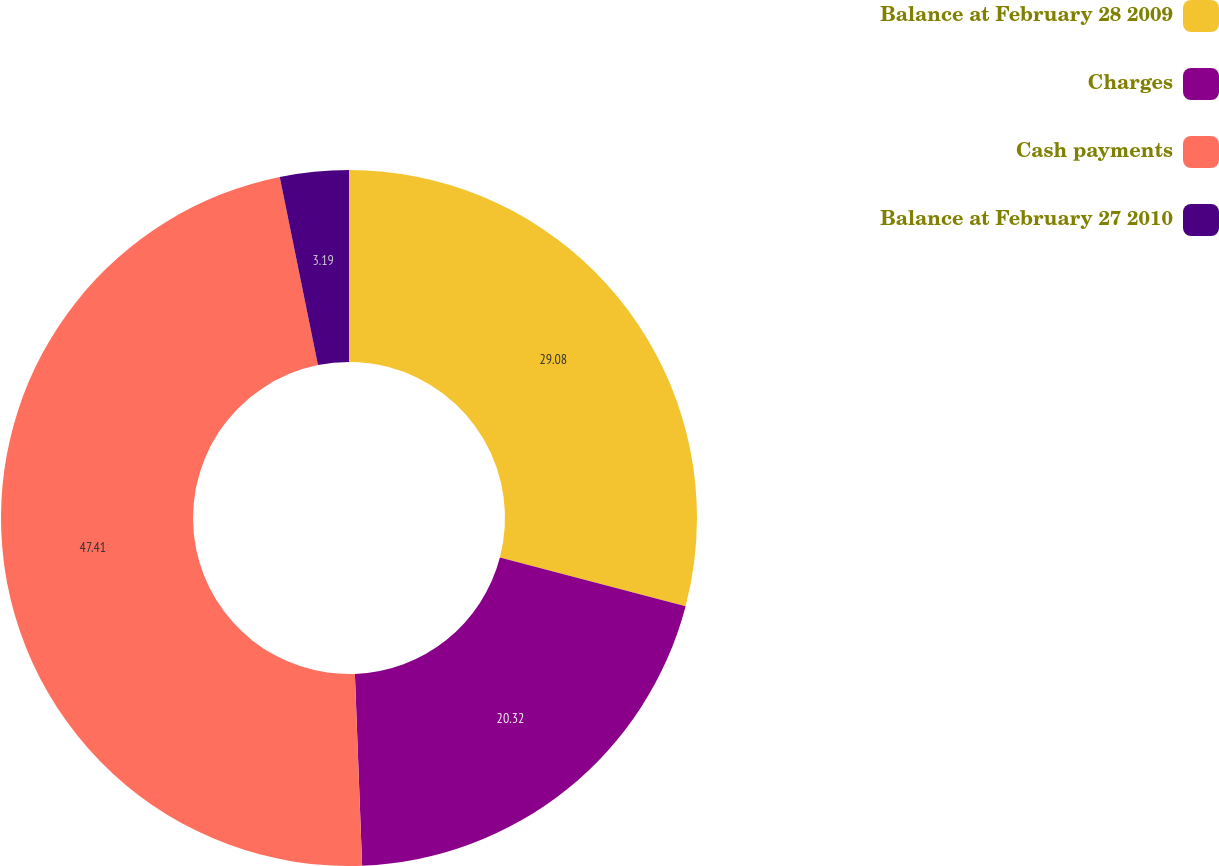<chart> <loc_0><loc_0><loc_500><loc_500><pie_chart><fcel>Balance at February 28 2009<fcel>Charges<fcel>Cash payments<fcel>Balance at February 27 2010<nl><fcel>29.08%<fcel>20.32%<fcel>47.41%<fcel>3.19%<nl></chart> 